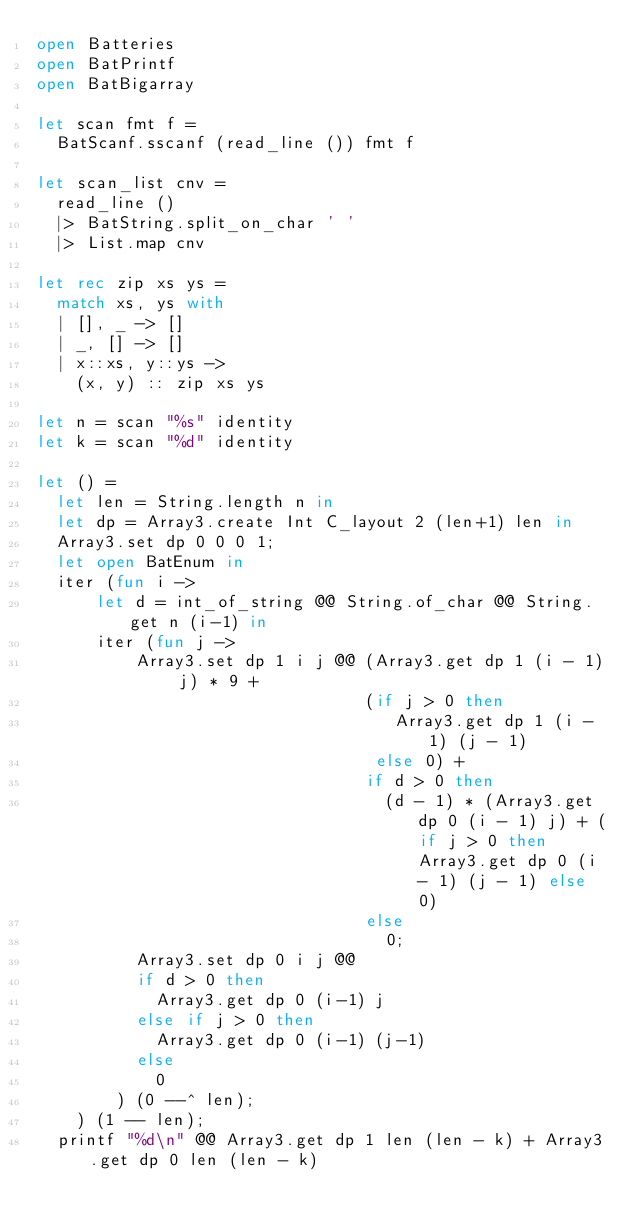Convert code to text. <code><loc_0><loc_0><loc_500><loc_500><_OCaml_>open Batteries
open BatPrintf
open BatBigarray

let scan fmt f =
  BatScanf.sscanf (read_line ()) fmt f

let scan_list cnv =
  read_line ()
  |> BatString.split_on_char ' '
  |> List.map cnv

let rec zip xs ys =
  match xs, ys with
  | [], _ -> []
  | _, [] -> []
  | x::xs, y::ys ->
    (x, y) :: zip xs ys

let n = scan "%s" identity
let k = scan "%d" identity

let () =
  let len = String.length n in
  let dp = Array3.create Int C_layout 2 (len+1) len in
  Array3.set dp 0 0 0 1;
  let open BatEnum in
  iter (fun i ->
      let d = int_of_string @@ String.of_char @@ String.get n (i-1) in
      iter (fun j ->
          Array3.set dp 1 i j @@ (Array3.get dp 1 (i - 1) j) * 9 +
                                 (if j > 0 then
                                    Array3.get dp 1 (i - 1) (j - 1)
                                  else 0) +
                                 if d > 0 then
                                   (d - 1) * (Array3.get dp 0 (i - 1) j) + (if j > 0 then Array3.get dp 0 (i - 1) (j - 1) else 0)
                                 else
                                   0;
          Array3.set dp 0 i j @@
          if d > 0 then
            Array3.get dp 0 (i-1) j
          else if j > 0 then
            Array3.get dp 0 (i-1) (j-1)
          else
            0
        ) (0 --^ len);
    ) (1 -- len);
  printf "%d\n" @@ Array3.get dp 1 len (len - k) + Array3.get dp 0 len (len - k)
</code> 